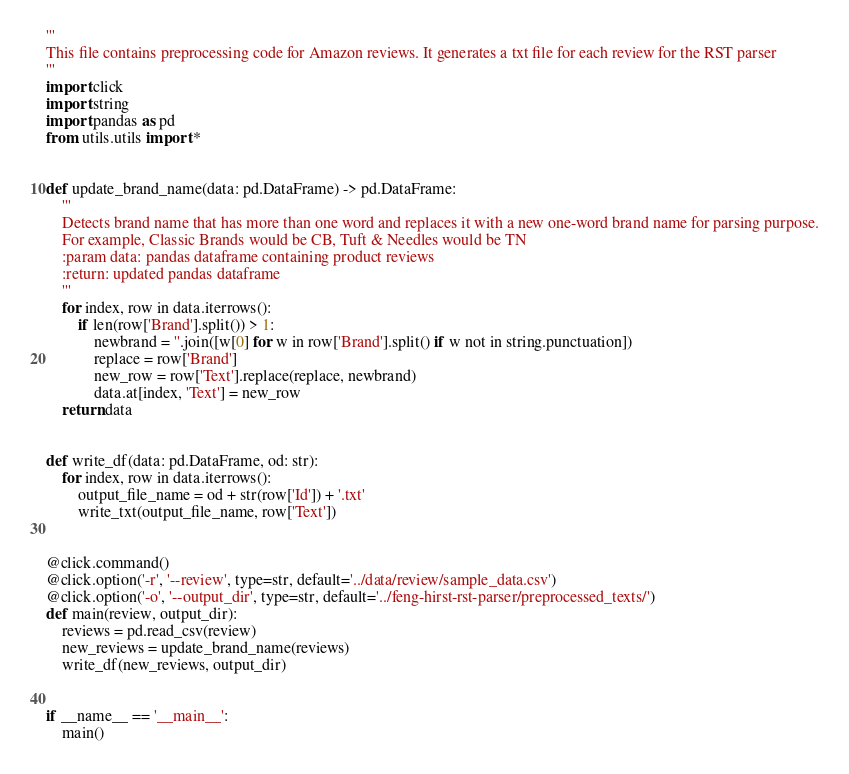<code> <loc_0><loc_0><loc_500><loc_500><_Python_>'''
This file contains preprocessing code for Amazon reviews. It generates a txt file for each review for the RST parser
'''
import click
import string
import pandas as pd
from utils.utils import *


def update_brand_name(data: pd.DataFrame) -> pd.DataFrame:
    '''
    Detects brand name that has more than one word and replaces it with a new one-word brand name for parsing purpose.
    For example, Classic Brands would be CB, Tuft & Needles would be TN
    :param data: pandas dataframe containing product reviews
    :return: updated pandas dataframe
    '''
    for index, row in data.iterrows():
        if len(row['Brand'].split()) > 1:
            newbrand = ''.join([w[0] for w in row['Brand'].split() if w not in string.punctuation])
            replace = row['Brand']
            new_row = row['Text'].replace(replace, newbrand)
            data.at[index, 'Text'] = new_row
    return data


def write_df(data: pd.DataFrame, od: str):
    for index, row in data.iterrows():
        output_file_name = od + str(row['Id']) + '.txt'
        write_txt(output_file_name, row['Text'])


@click.command()
@click.option('-r', '--review', type=str, default='../data/review/sample_data.csv')
@click.option('-o', '--output_dir', type=str, default='../feng-hirst-rst-parser/preprocessed_texts/')
def main(review, output_dir):
    reviews = pd.read_csv(review)
    new_reviews = update_brand_name(reviews)
    write_df(new_reviews, output_dir)


if __name__ == '__main__':
    main()




</code> 